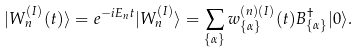Convert formula to latex. <formula><loc_0><loc_0><loc_500><loc_500>| W _ { n } ^ { ( I ) } ( t ) \rangle = e ^ { - i E _ { n } t } | W _ { n } ^ { ( I ) } \rangle = \sum _ { \{ \alpha \} } w _ { \{ \alpha \} } ^ { ( n ) ( I ) } ( t ) B _ { \{ \alpha \} } ^ { \dagger } | 0 \rangle .</formula> 